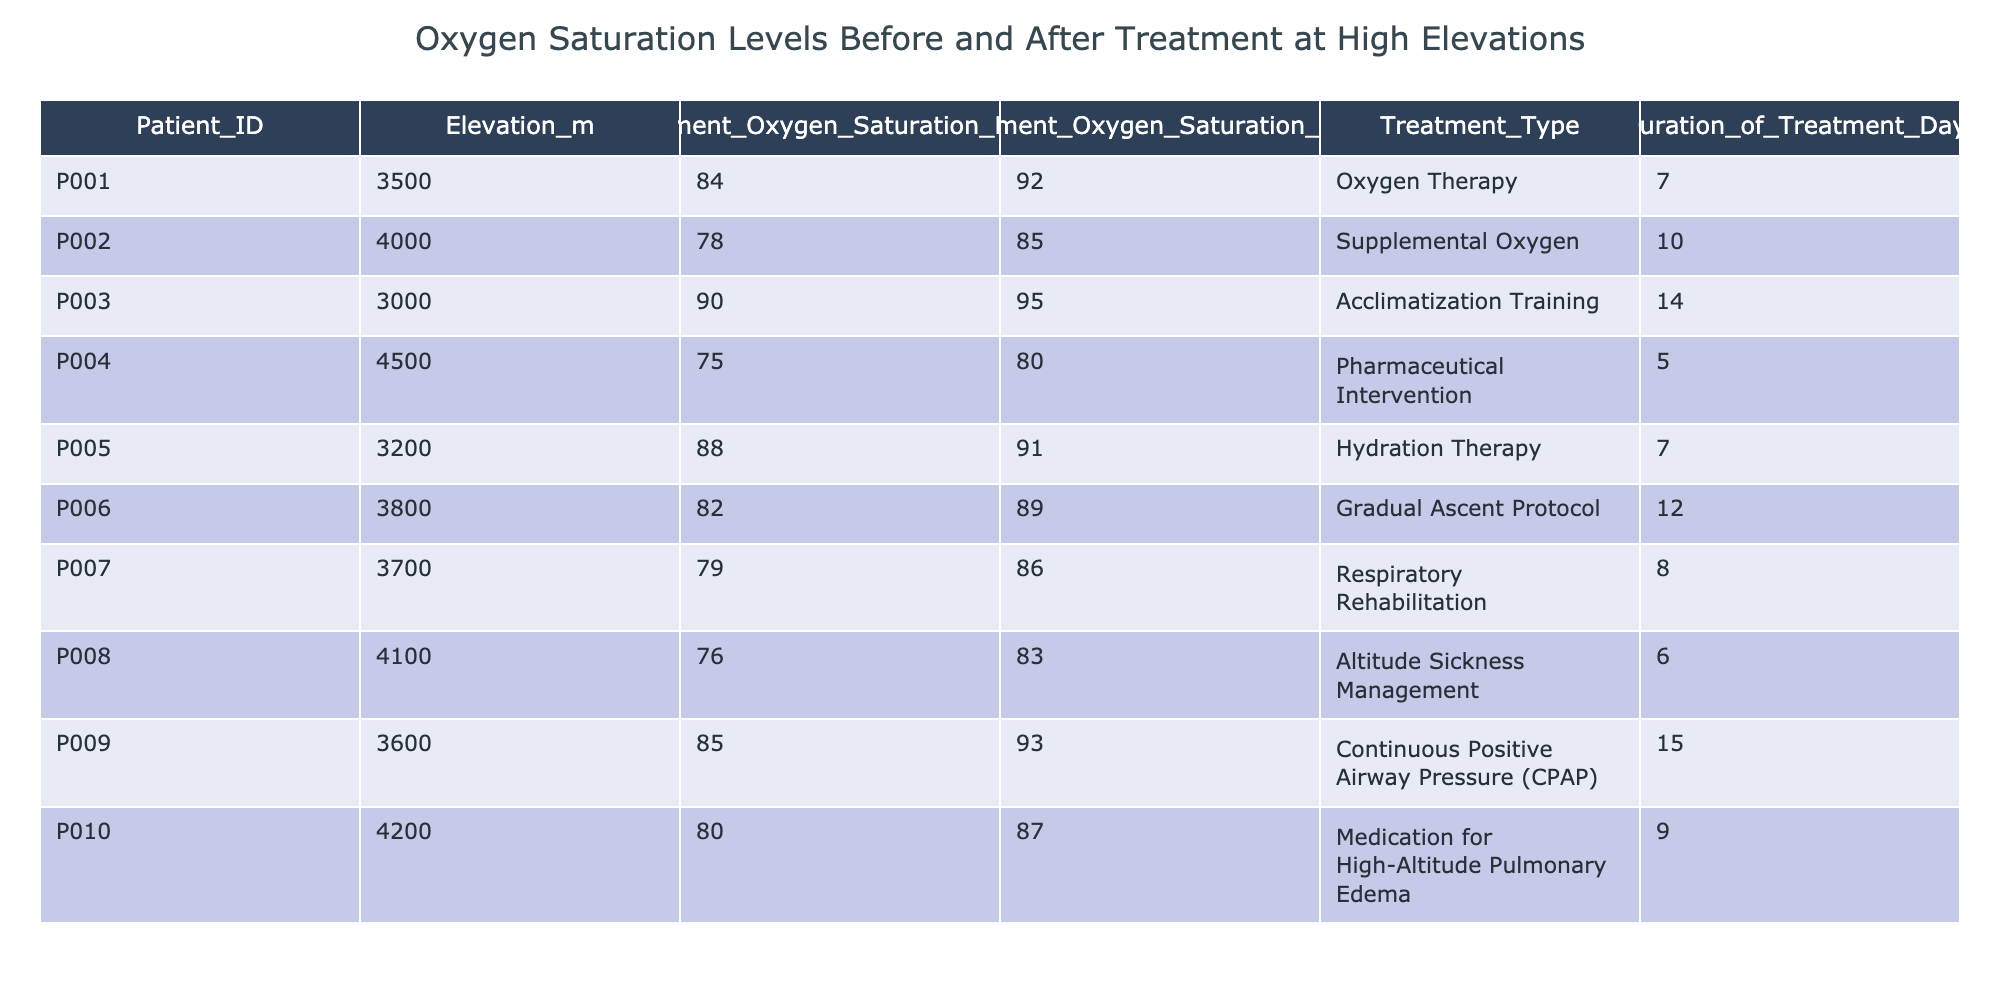What was the highest pre-treatment oxygen saturation percentage recorded? Scanning through the "Pre_Treatment_Oxygen_Saturation_Percentage" column, the highest value is 90, which corresponds to Patient_ID P003.
Answer: 90 What treatment had the longest duration? Looking at the "Duration_of_Treatment_Days" column, the maximum value is 15 days for the treatment type "Continuous Positive Airway Pressure (CPAP)" associated with Patient_ID P009.
Answer: 15 days What is the average post-treatment oxygen saturation percentage across all patients? Adding the post-treatment saturation values (92 + 85 + 95 + 80 + 91 + 89 + 86 + 83 + 93 + 87) gives a total of 900. Dividing by the number of patients (10) results in an average of 90.
Answer: 90 Did any patient achieve an increase in oxygen saturation of more than 10 percentage points after treatment? By calculating the increase for each patient (Post - Pre), the following increases are found: P001 (8), P002 (7), P003 (5), P004 (5), P005 (3), P006 (7), P007 (7), P008 (7), P009 (8), P010 (7). None of these increases exceed 10 points.
Answer: No Which treatment type resulted in the lowest post-treatment oxygen saturation percentage? In the "Post_Treatment_Oxygen_Saturation_Percentage" column, the lowest value is 80, which corresponds to the "Pharmaceutical Intervention" for Patient_ID P004.
Answer: Pharmaceutical Intervention What treatment is associated with the patient who had the lowest pre-treatment oxygen saturation percentage? The lowest pre-treatment saturation percentage is 75 for Patient_ID P004, and the associated treatment type is "Pharmaceutical Intervention."
Answer: Pharmaceutical Intervention Which patient showed the greatest improvement in oxygen saturation levels? To find the greatest improvement, calculate each patient's change in saturation: P001 (8), P002 (7), P003 (5), P004 (5), P005 (3), P006 (7), P007 (7), P008 (7), P009 (8), P010 (7). The maximum increase is 8 for both P001 and P009.
Answer: P001 and P009 Is there a patient who underwent "Hydration Therapy" that had a post-treatment saturation that meets or exceeds 90? Checking the records, Patient_ID P005 underwent "Hydration Therapy" and had a post-treatment saturation of 91, which exceeds 90.
Answer: Yes 